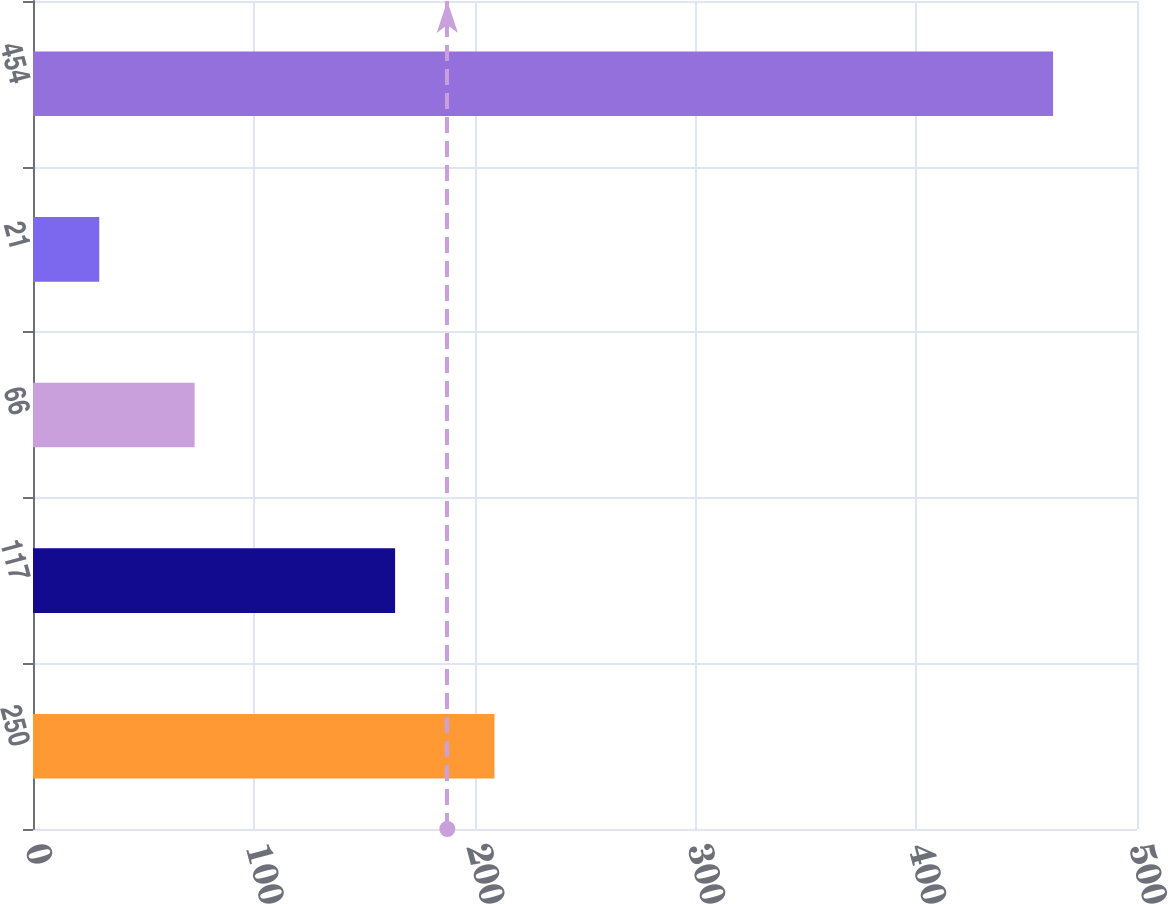Convert chart. <chart><loc_0><loc_0><loc_500><loc_500><bar_chart><fcel>250<fcel>117<fcel>66<fcel>21<fcel>454<nl><fcel>209<fcel>164<fcel>73.2<fcel>30<fcel>462<nl></chart> 